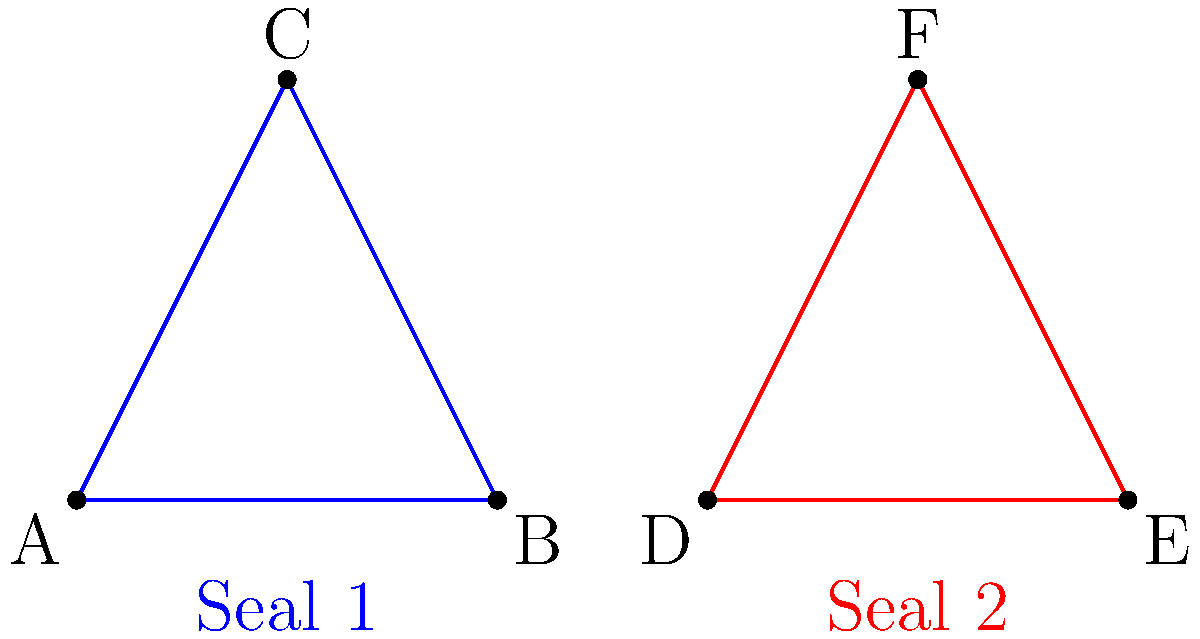In a legal document authentication process, two triangular seals are used. Seal 1 (blue) has vertices at points A(0,0), B(2,0), and C(1,2), while Seal 2 (red) has vertices at points D(3,0), E(5,0), and F(4,2). Are these seals congruent, and if so, what transformation would map Seal 1 onto Seal 2? To determine if the seals are congruent and identify the transformation, let's follow these steps:

1. Check if the triangles have the same shape and size:
   - Both triangles are isosceles with a vertical line of symmetry.
   - The base of both triangles is 2 units (AB = 2, DE = 2).
   - The height of both triangles is 2 units (from the midpoint of the base to the top vertex).

2. Verify congruence:
   - Since the triangles have the same base length and height, they are congruent.

3. Identify the transformation:
   - The triangles have the same orientation (not flipped or rotated).
   - Seal 2 appears to be shifted to the right of Seal 1.

4. Calculate the translation:
   - The difference between corresponding points:
     D(3,0) - A(0,0) = (3,0)
     E(5,0) - B(2,0) = (3,0)
     F(4,2) - C(1,2) = (3,0)

5. Conclusion:
   The seals are congruent, and Seal 2 can be obtained by translating Seal 1 by the vector (3,0), which represents a rightward shift of 3 units.
Answer: Yes; translation by vector (3,0) 